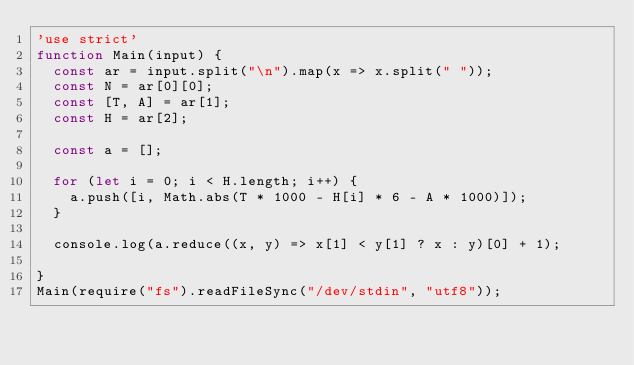<code> <loc_0><loc_0><loc_500><loc_500><_JavaScript_>'use strict'
function Main(input) {
  const ar = input.split("\n").map(x => x.split(" "));
  const N = ar[0][0];
  const [T, A] = ar[1];
  const H = ar[2];
 
  const a = [];
 
  for (let i = 0; i < H.length; i++) {
    a.push([i, Math.abs(T * 1000 - H[i] * 6 - A * 1000)]);
  }
 
  console.log(a.reduce((x, y) => x[1] < y[1] ? x : y)[0] + 1);
 
}
Main(require("fs").readFileSync("/dev/stdin", "utf8"));</code> 